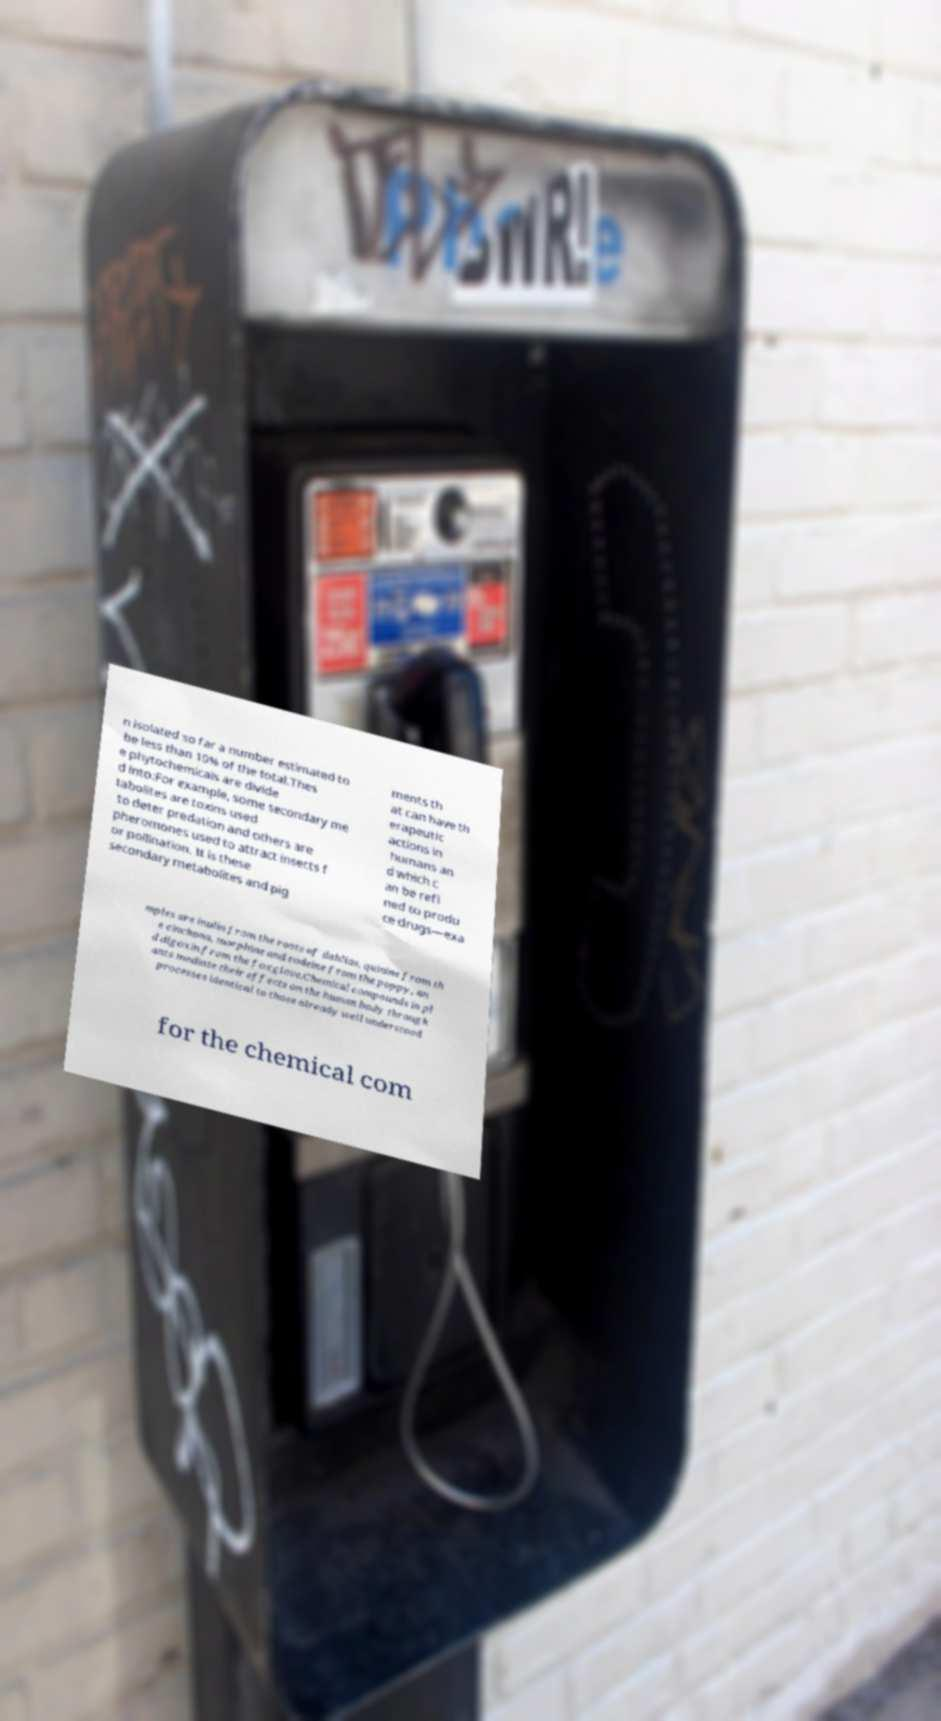I need the written content from this picture converted into text. Can you do that? n isolated so far a number estimated to be less than 10% of the total.Thes e phytochemicals are divide d into:For example, some secondary me tabolites are toxins used to deter predation and others are pheromones used to attract insects f or pollination. It is these secondary metabolites and pig ments th at can have th erapeutic actions in humans an d which c an be refi ned to produ ce drugs—exa mples are inulin from the roots of dahlias, quinine from th e cinchona, morphine and codeine from the poppy, an d digoxin from the foxglove.Chemical compounds in pl ants mediate their effects on the human body through processes identical to those already well understood for the chemical com 